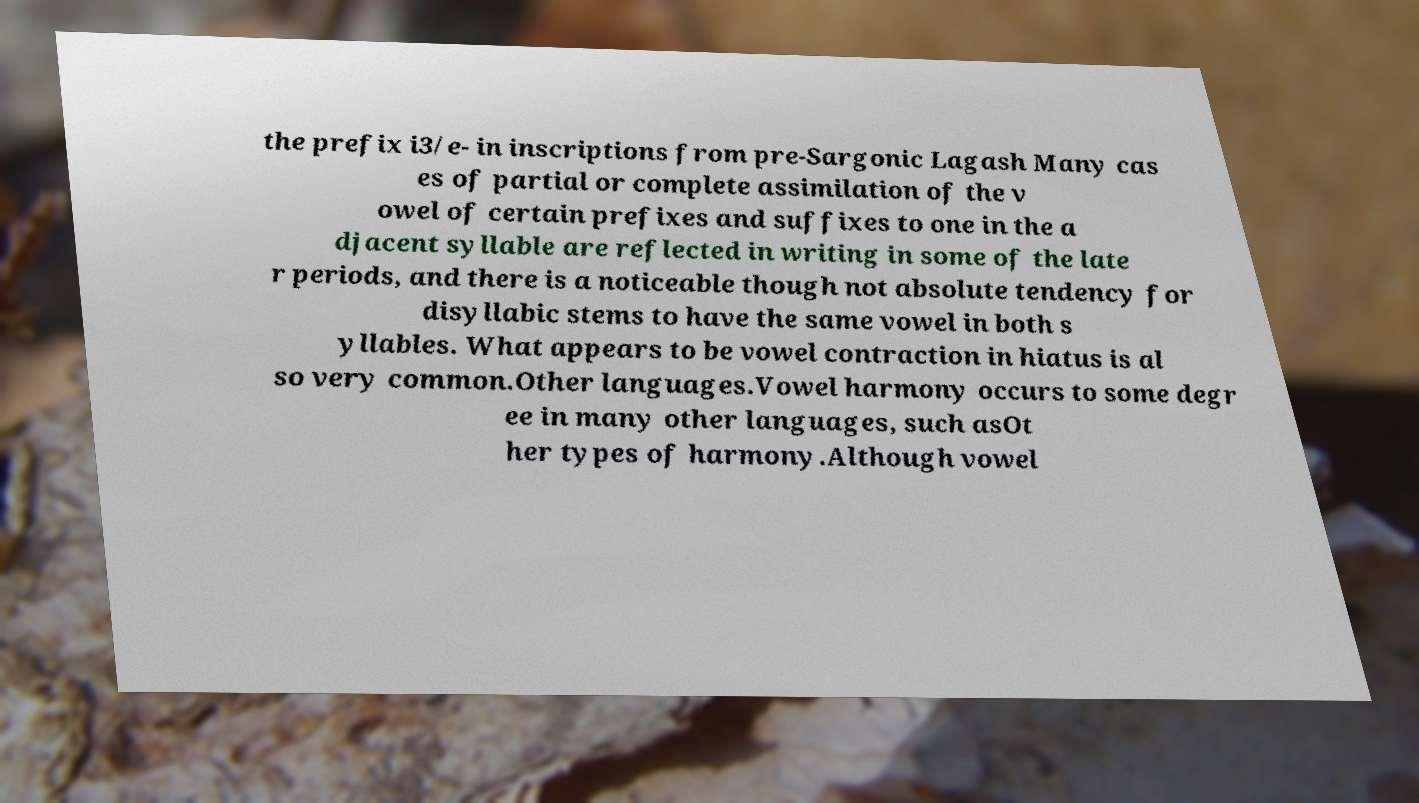Please identify and transcribe the text found in this image. the prefix i3/e- in inscriptions from pre-Sargonic Lagash Many cas es of partial or complete assimilation of the v owel of certain prefixes and suffixes to one in the a djacent syllable are reflected in writing in some of the late r periods, and there is a noticeable though not absolute tendency for disyllabic stems to have the same vowel in both s yllables. What appears to be vowel contraction in hiatus is al so very common.Other languages.Vowel harmony occurs to some degr ee in many other languages, such asOt her types of harmony.Although vowel 